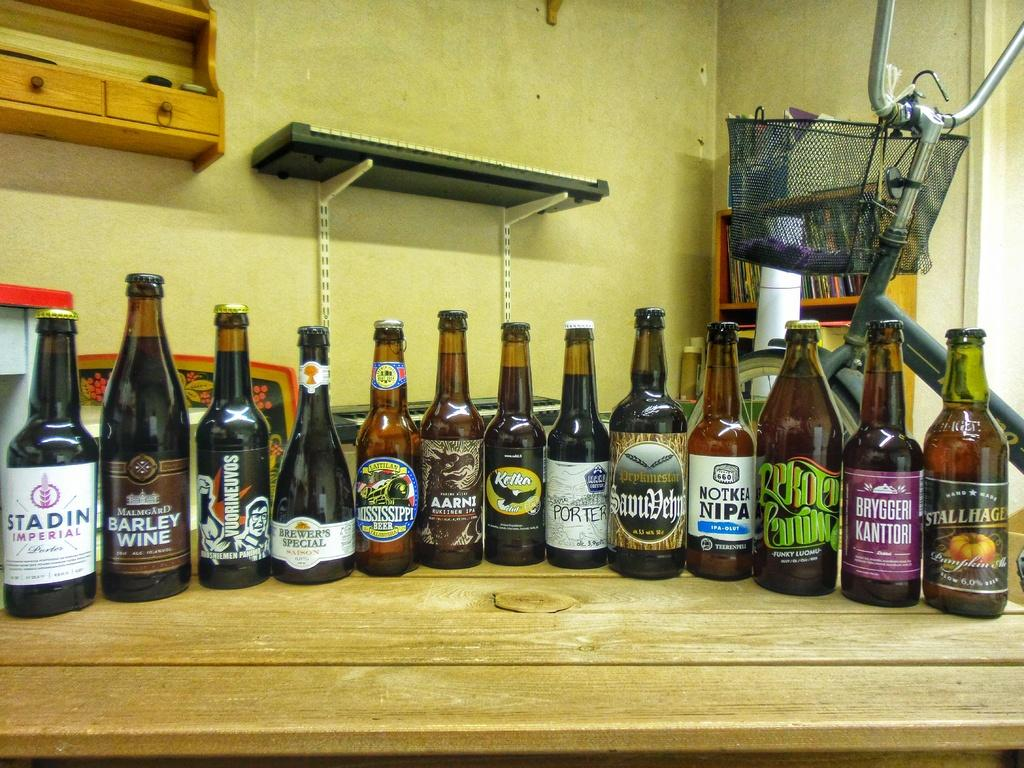<image>
Relay a brief, clear account of the picture shown. A bottle of Stadin Imperial is in line with several other bottles on a wooden surface. 